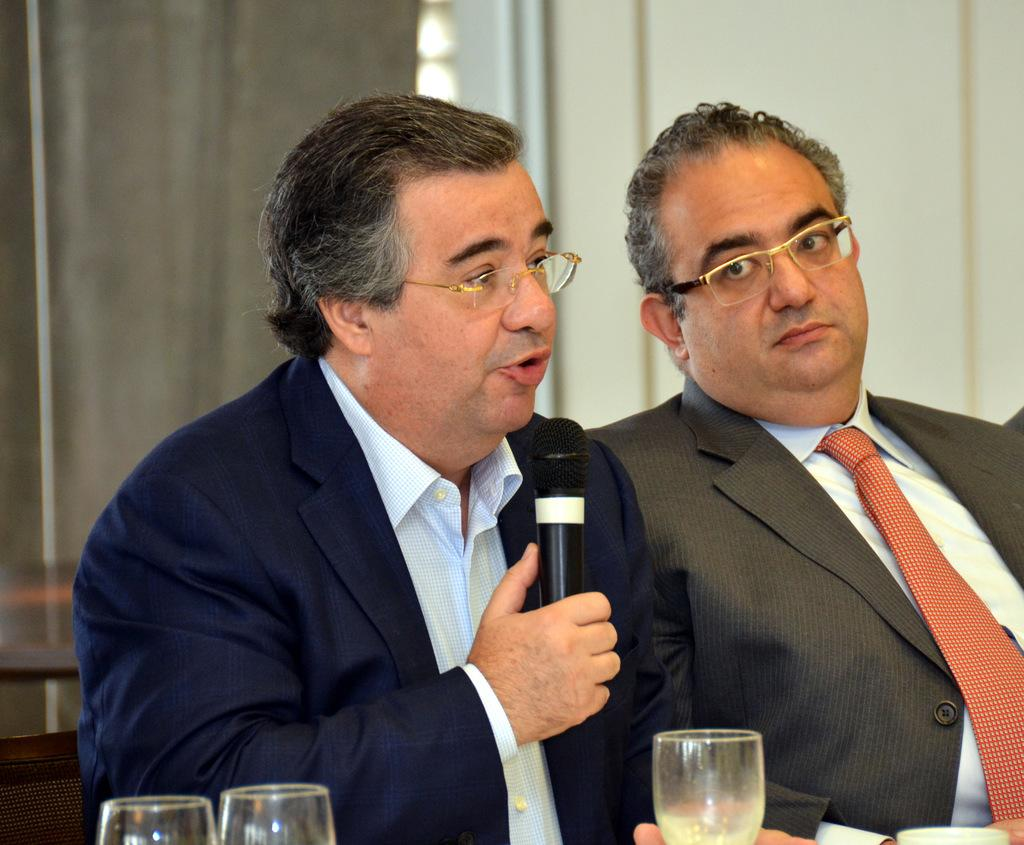How many people are sitting in the image? There are 2 people sitting in the image. What are the people wearing? Both people are wearing suits. What is the person on the left holding? The person on the left is holding a microphone. What is the person on the left doing? The person on the left is speaking. What objects are in front of the people? There are glasses in front of the people. What can be seen in the background of the image? There are curtains and a wall in the background. What type of ink is being used to write on the lace in the image? There is no ink or lace present in the image; it features two people sitting and speaking. Is there a bear visible in the image? No, there is no bear present in the image. 